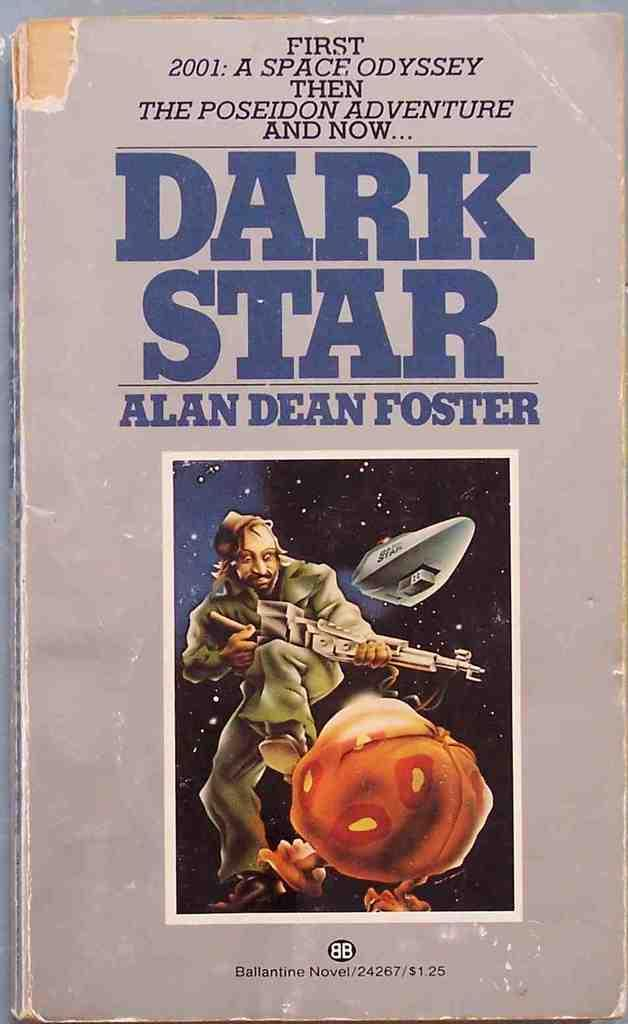What is the main subject of the image? There is a book in the center of the image. Can you describe the book in the image? Unfortunately, the image does not provide enough detail to describe the book further. How many grapes are on the book in the image? There are no grapes present on the book in the image. 